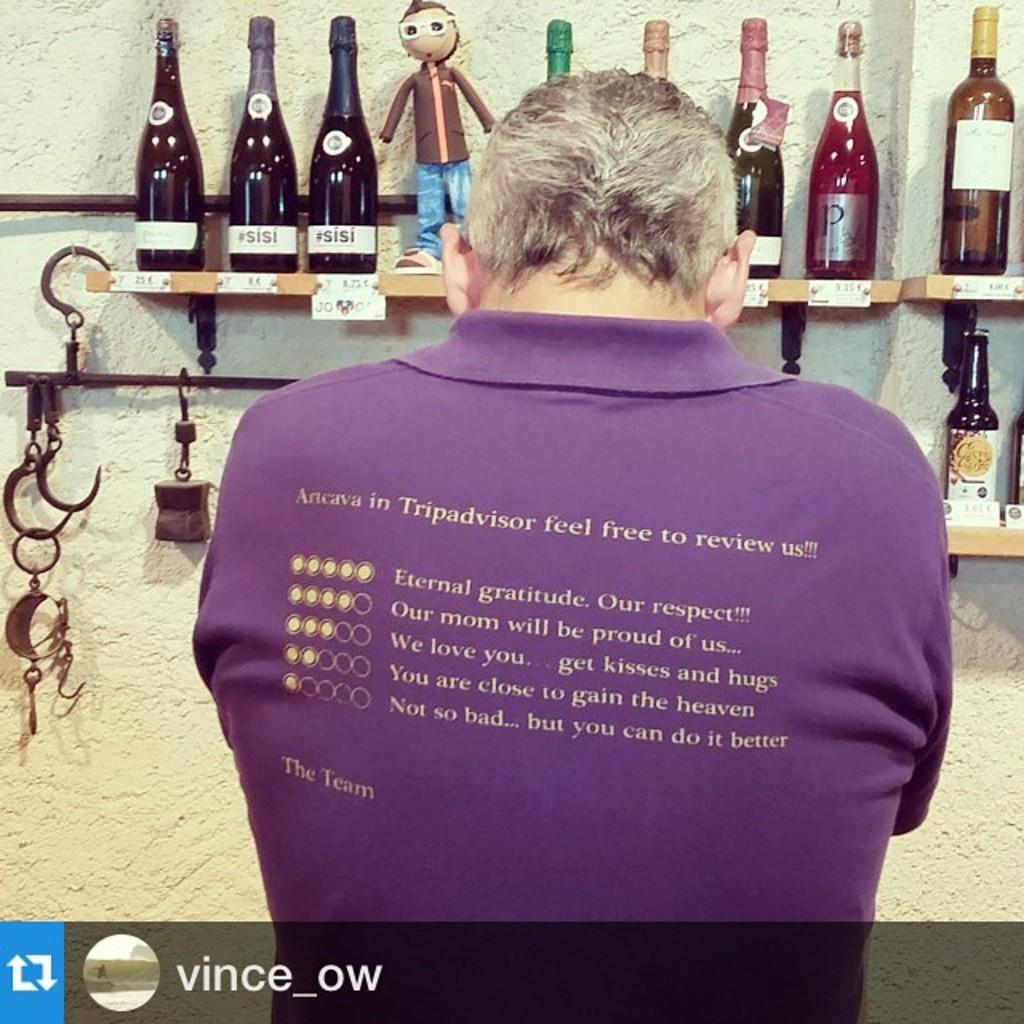What is the main subject of the image? There is a man standing in the image. What is in front of the man? There is a wall in front of the man. What is unique about the wall? Wine bottles are attached to the wall. What type of medical equipment can be seen in the image? There is no medical equipment present in the image; it features a man standing in front of a wall with wine bottles attached to it. What kind of owl is perched on the man's shoulder in the image? There is no owl present in the image. 